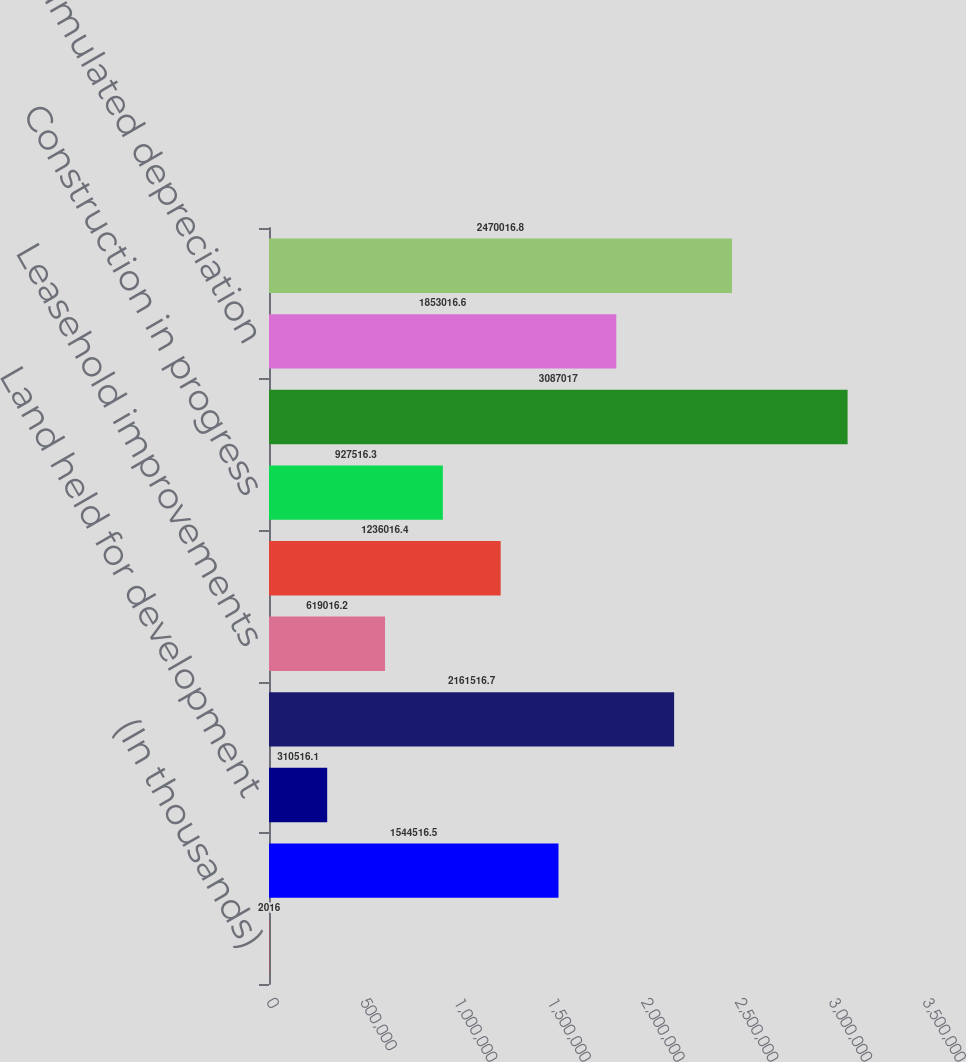<chart> <loc_0><loc_0><loc_500><loc_500><bar_chart><fcel>(In thousands)<fcel>Land<fcel>Land held for development<fcel>Buildings<fcel>Leasehold improvements<fcel>Furniture fixtures and<fcel>Construction in progress<fcel>Total property and equipment<fcel>Less accumulated depreciation<fcel>Property and equipment net<nl><fcel>2016<fcel>1.54452e+06<fcel>310516<fcel>2.16152e+06<fcel>619016<fcel>1.23602e+06<fcel>927516<fcel>3.08702e+06<fcel>1.85302e+06<fcel>2.47002e+06<nl></chart> 